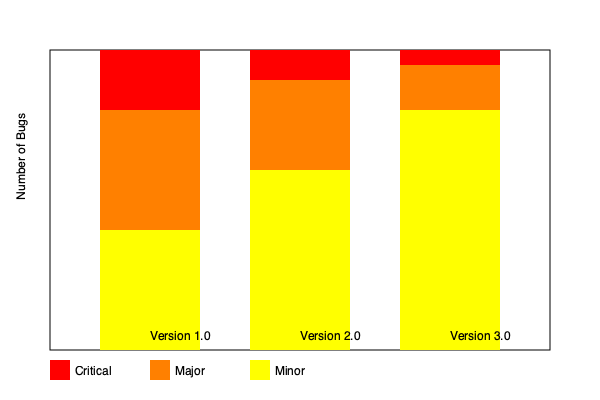Based on the stacked bar chart showing bug severity distribution across product versions, which version demonstrates the most significant improvement in overall product stability, and why? To determine which version demonstrates the most significant improvement in overall product stability, we need to analyze the distribution of bug severities across versions:

1. Examine Version 1.0 (leftmost bar):
   - High number of critical (red) and major (orange) bugs
   - Relatively fewer minor (yellow) bugs

2. Analyze Version 2.0 (middle bar):
   - Reduction in critical bugs
   - Slight decrease in major bugs
   - Increase in minor bugs

3. Evaluate Version 3.0 (rightmost bar):
   - Further reduction in critical bugs
   - Significant decrease in major bugs
   - Large increase in minor bugs

4. Compare the transitions:
   - 1.0 to 2.0: Moderate improvement, with some critical and major bugs resolved
   - 2.0 to 3.0: Substantial improvement, with a significant shift from critical and major to minor bugs

5. Interpret the results:
   - The shift from higher severity (critical and major) to lower severity (minor) bugs indicates improved stability
   - Version 3.0 shows the most dramatic reduction in critical and major bugs, with the highest proportion of minor bugs

6. Consider the stakeholder perspective:
   - As a stakeholder valuing well-tested and stable products, the version with the least critical and major bugs is preferred
   - Version 3.0 aligns best with this preference, showing the most mature and stable state

Therefore, Version 3.0 demonstrates the most significant improvement in overall product stability due to the substantial reduction in critical and major bugs, and the highest proportion of minor bugs.
Answer: Version 3.0 